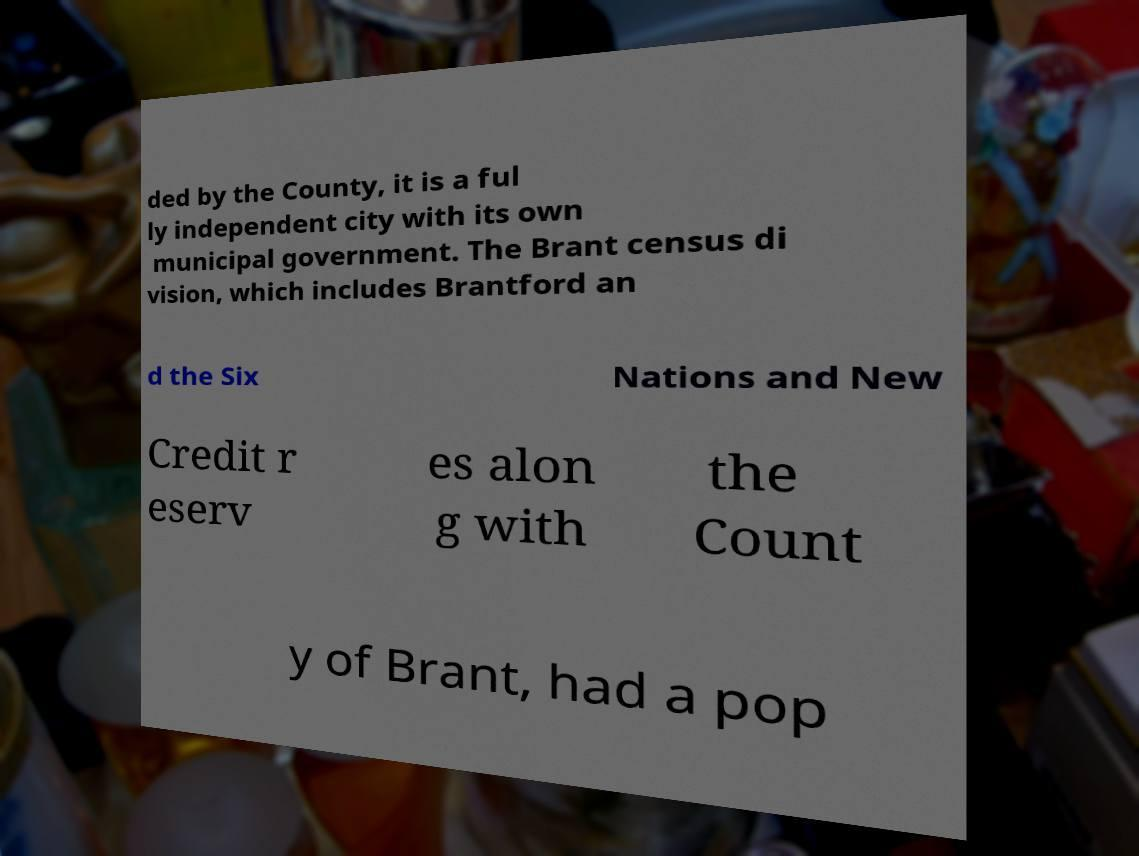Could you extract and type out the text from this image? ded by the County, it is a ful ly independent city with its own municipal government. The Brant census di vision, which includes Brantford an d the Six Nations and New Credit r eserv es alon g with the Count y of Brant, had a pop 